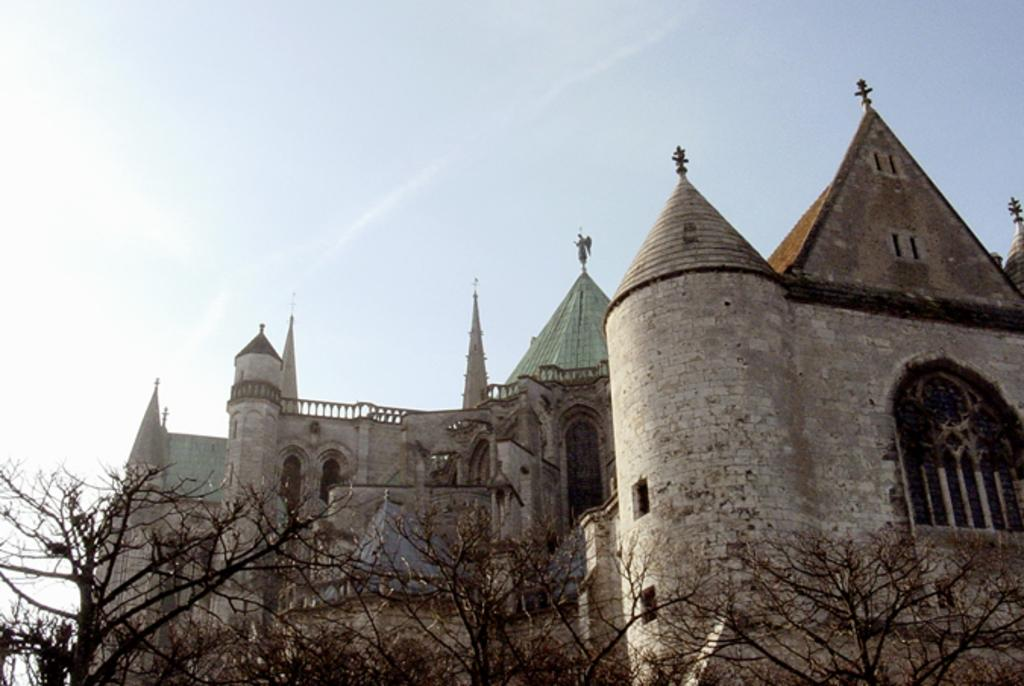What type of structure is present in the image? There is a building in the image. What can be seen at the bottom of the image? There are trees at the bottom of the image. What is visible at the top of the image? The sky is visible at the top of the image. Where is the receipt for the building located in the image? There is no receipt present in the image. What type of sheet is covering the trees in the image? There is no sheet covering the trees in the image. 